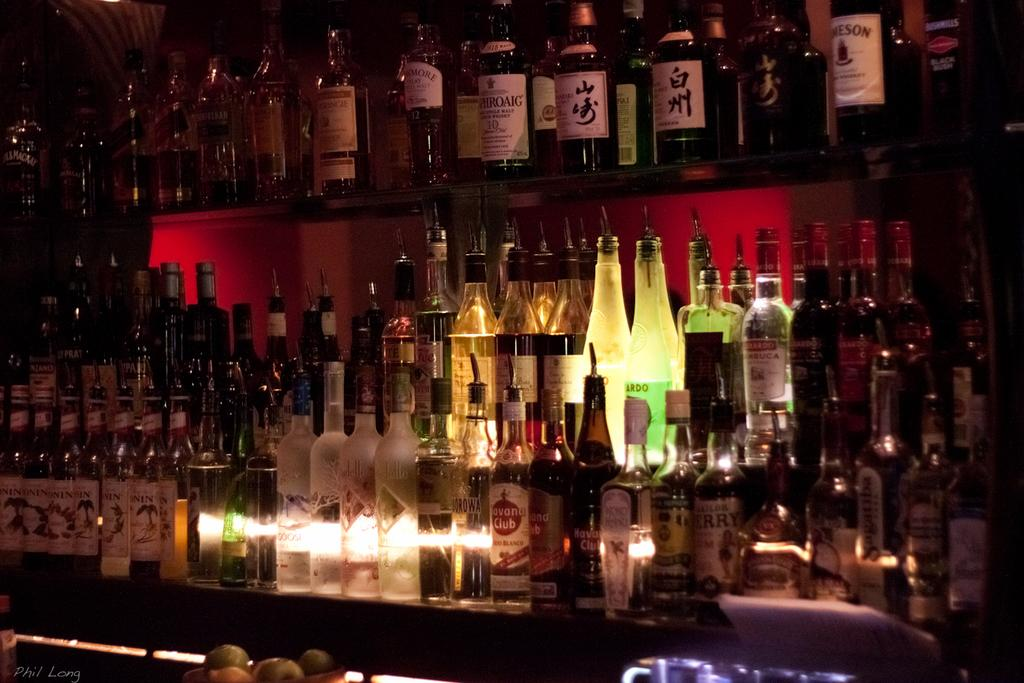What objects are present in the image? There are bottles in the image. How are the bottles positioned in the image? The bottles are placed in shelves. How are the bottles arranged on the shelves? The bottles are arranged in a row. What type of acoustics can be heard coming from the bottles in the image? There is no indication in the image that the bottles are producing any sound or acoustics. What type of material are the bottles made of in the image? The provided facts do not specify the material of the bottles, but they are commonly made of glass. 